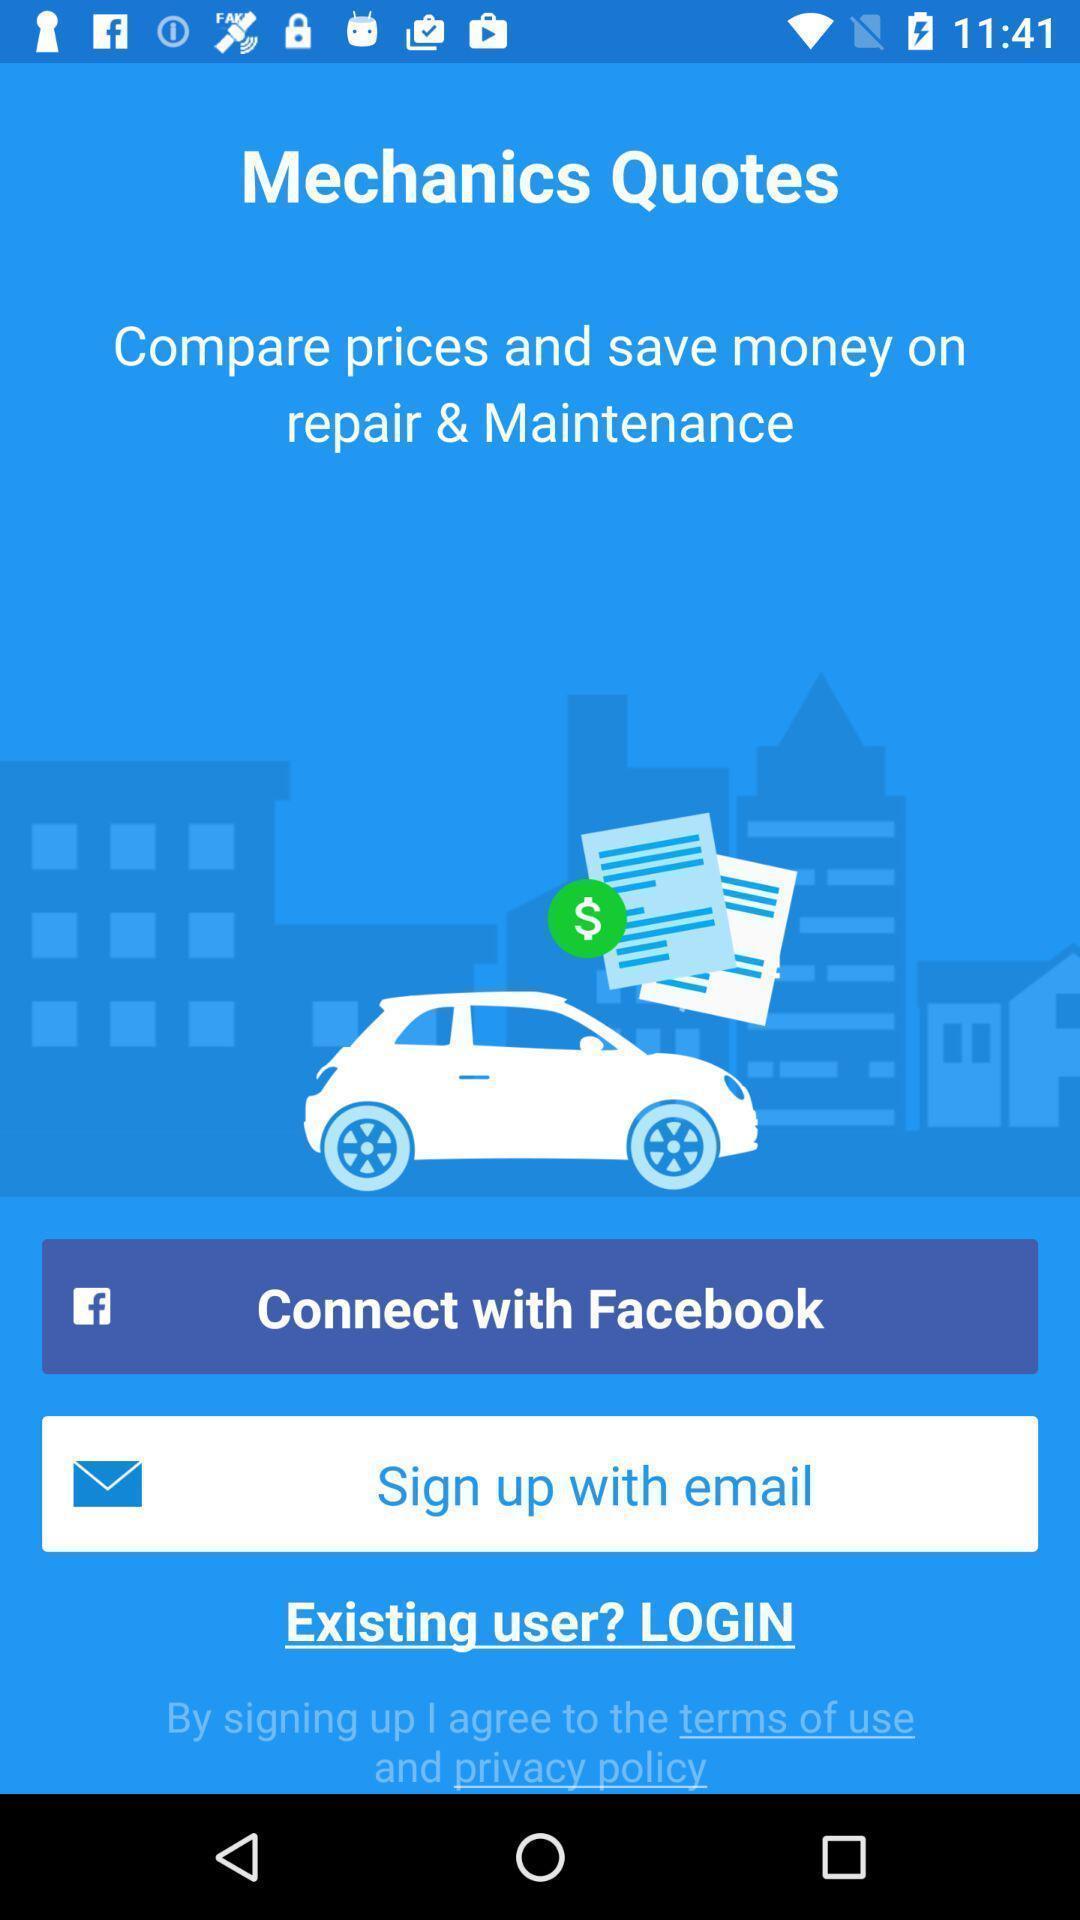Summarize the main components in this picture. Welcome page of the map. 